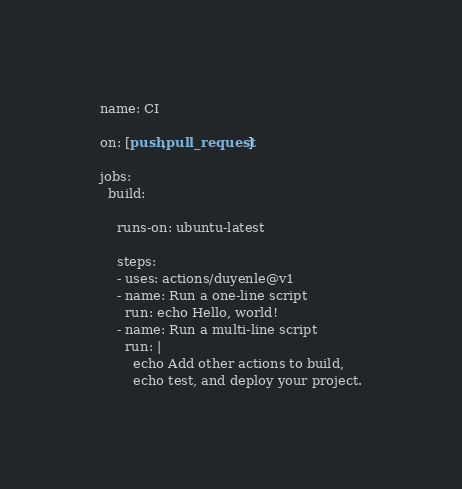<code> <loc_0><loc_0><loc_500><loc_500><_YAML_>name: CI

on: [push,pull_request]

jobs:
  build:

    runs-on: ubuntu-latest
    
    steps:
    - uses: actions/duyenle@v1
    - name: Run a one-line script
      run: echo Hello, world!
    - name: Run a multi-line script
      run: |
        echo Add other actions to build,
        echo test, and deploy your project.
</code> 